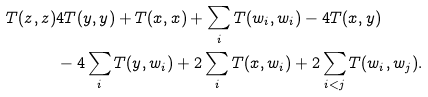<formula> <loc_0><loc_0><loc_500><loc_500>T ( z , z ) & 4 T ( y , y ) + T ( x , x ) + \sum _ { i } T ( w _ { i } , w _ { i } ) - 4 T ( x , y ) \\ & - 4 \sum _ { i } T ( y , w _ { i } ) + 2 \sum _ { i } T ( x , w _ { i } ) + 2 \sum _ { i < j } T ( w _ { i } , w _ { j } ) .</formula> 